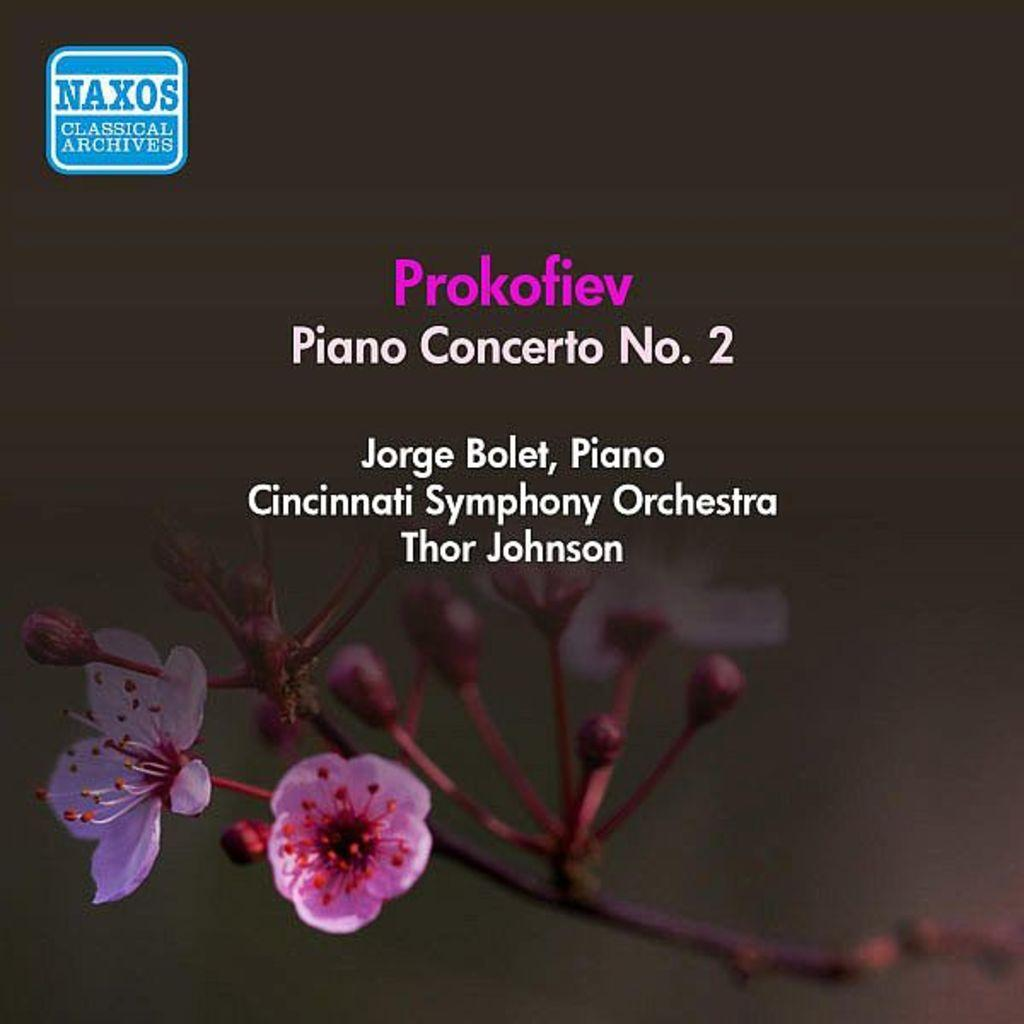<image>
Offer a succinct explanation of the picture presented. A page showing the Piano concerto No, 2 is being performed at the Cincinatti symphony. 